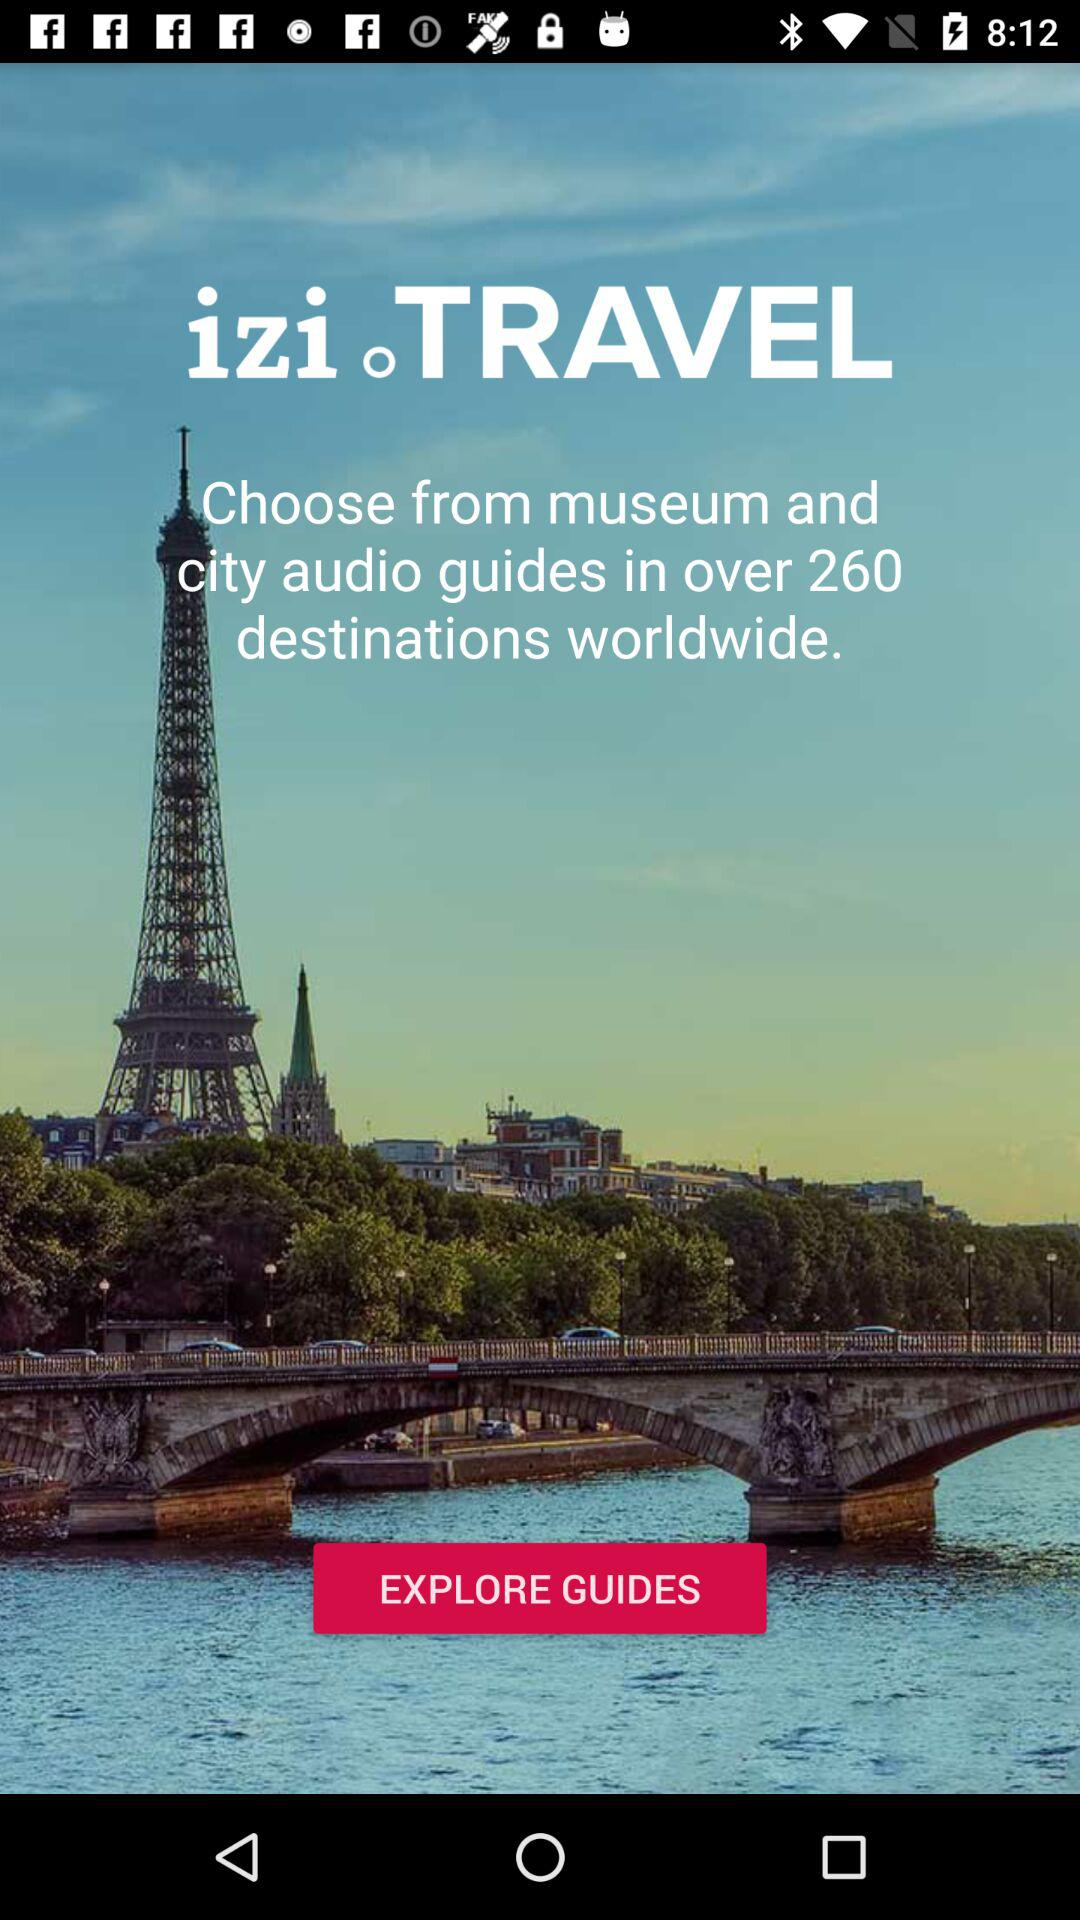What is the name of the application? The application name is "izi.TRAVEL". 